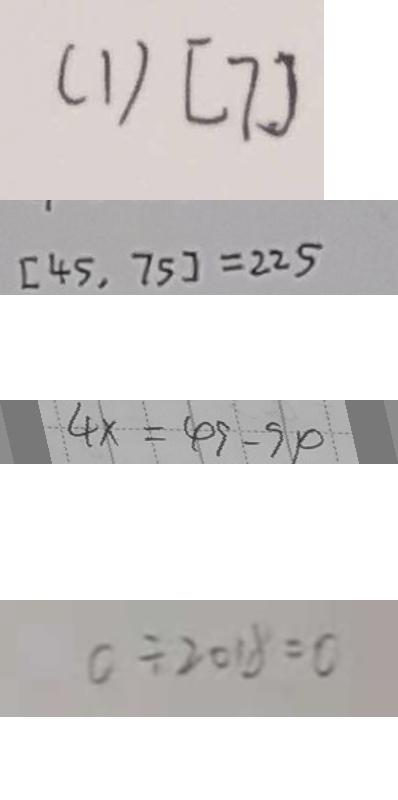Convert formula to latex. <formula><loc_0><loc_0><loc_500><loc_500>( 1 ) [ 7 ] 
 [ 4 5 , 7 5 ] = 2 2 5 
 4 x = 4 9 - 9 4 
 0 \div 2 0 1 8 = 0</formula> 